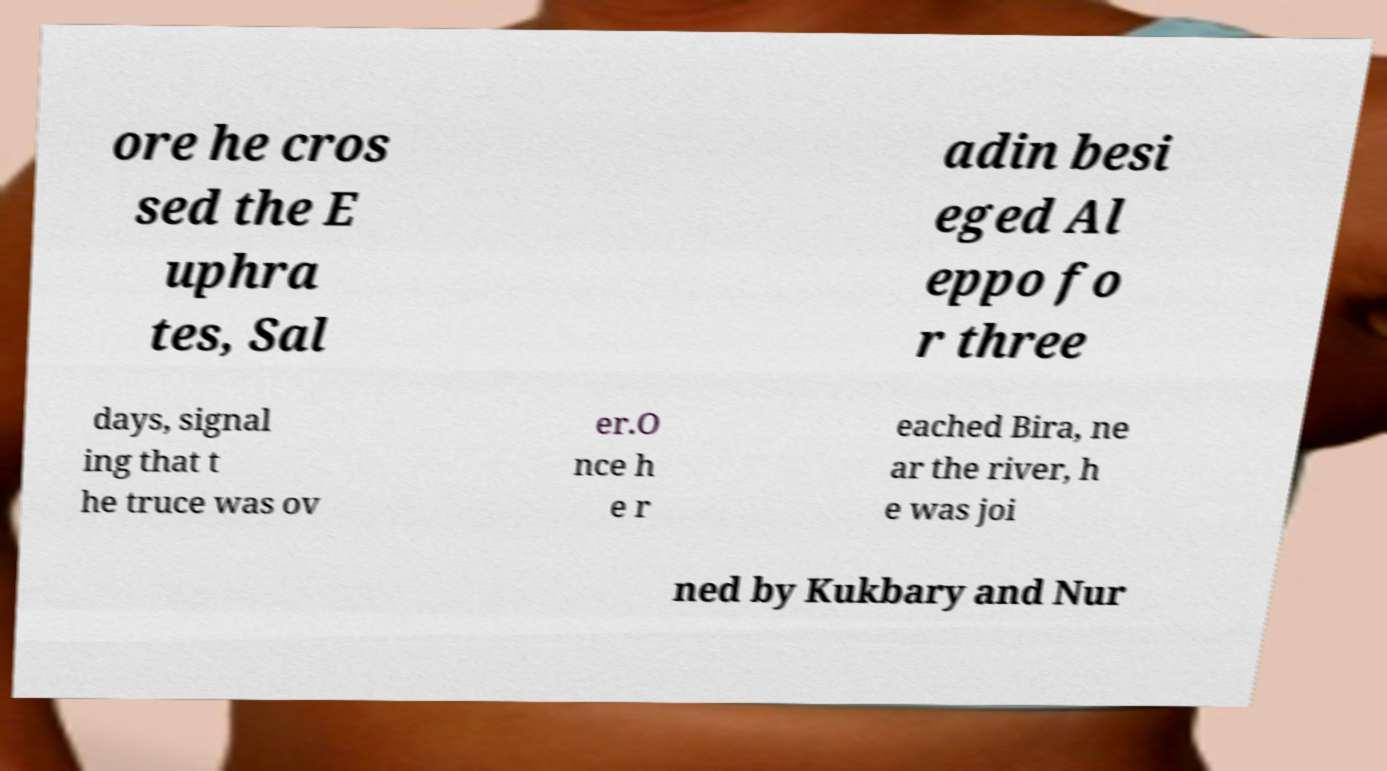Could you extract and type out the text from this image? ore he cros sed the E uphra tes, Sal adin besi eged Al eppo fo r three days, signal ing that t he truce was ov er.O nce h e r eached Bira, ne ar the river, h e was joi ned by Kukbary and Nur 